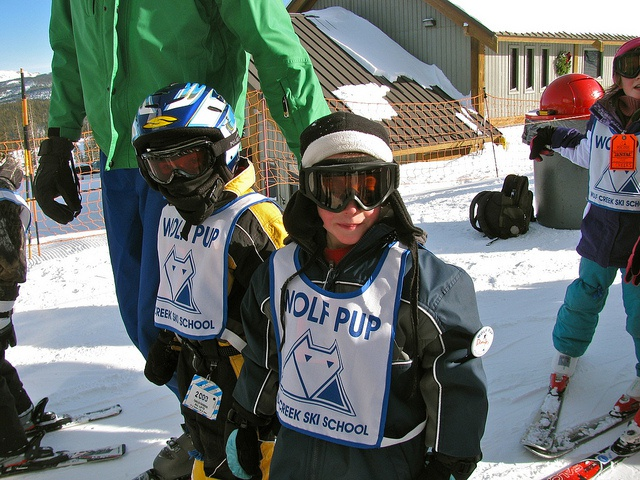Describe the objects in this image and their specific colors. I can see people in lightblue, black, darkgray, gray, and navy tones, people in lightblue, darkgreen, black, and navy tones, people in lightblue, black, darkgray, gray, and white tones, people in lightblue, black, teal, darkgray, and gray tones, and people in lightblue, black, gray, darkgray, and white tones in this image. 